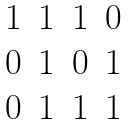<formula> <loc_0><loc_0><loc_500><loc_500>\begin{matrix} 1 & 1 & 1 & 0 \\ 0 & 1 & 0 & 1 \\ 0 & 1 & 1 & 1 \end{matrix}</formula> 